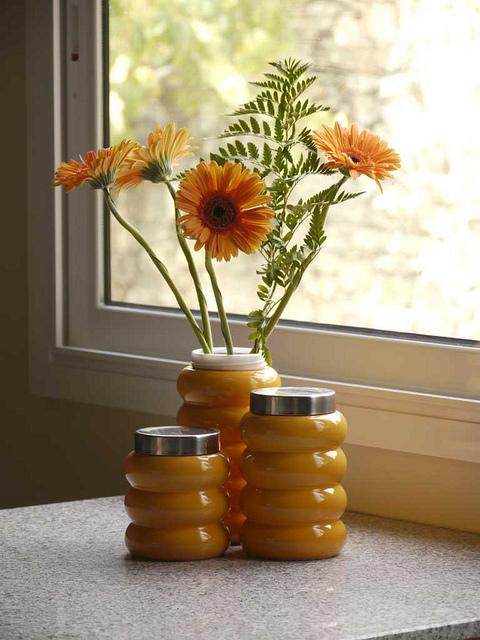What is the object in orange?
Concise answer only. Vase. What colors are the containers?
Quick response, please. Yellow. What is painted on the middle vase?
Quick response, please. Nothing. What color is the vase?
Concise answer only. Yellow. How many vases are in the picture?
Answer briefly. 3. What is the vase made of?
Write a very short answer. Glass. How many containers are on the counter?
Quick response, please. 3. What kind of flowers are these?
Quick response, please. Daisy. 